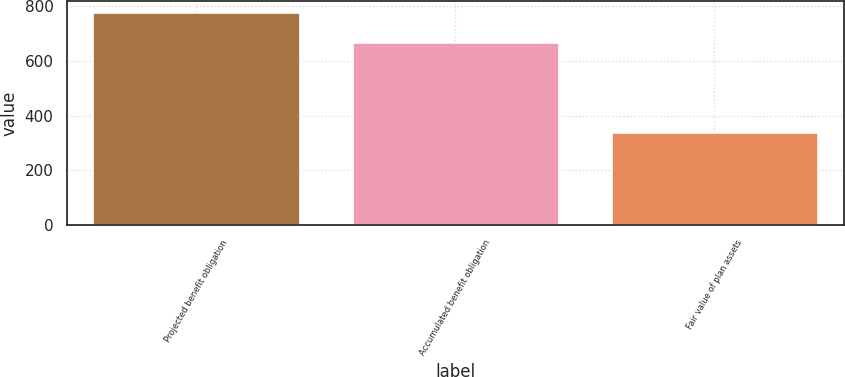Convert chart. <chart><loc_0><loc_0><loc_500><loc_500><bar_chart><fcel>Projected benefit obligation<fcel>Accumulated benefit obligation<fcel>Fair value of plan assets<nl><fcel>779<fcel>670<fcel>340<nl></chart> 